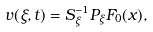Convert formula to latex. <formula><loc_0><loc_0><loc_500><loc_500>v ( \xi , t ) = S _ { \xi } ^ { - 1 } P _ { \xi } F _ { 0 } ( x ) ,</formula> 